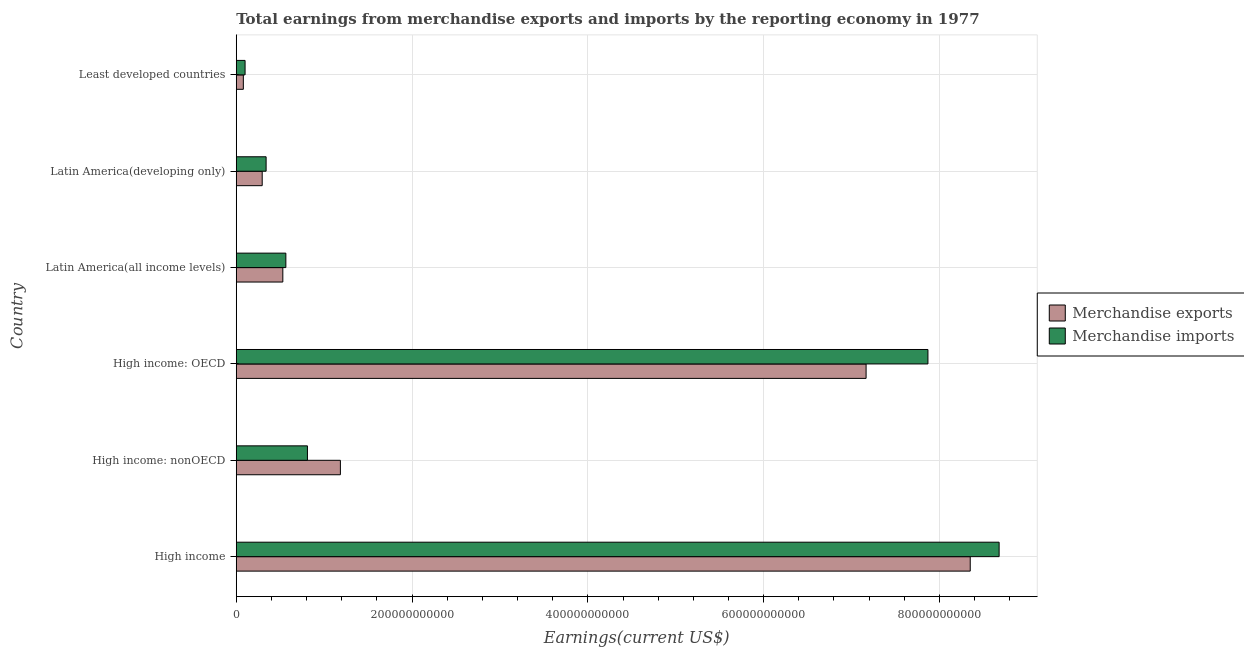Are the number of bars per tick equal to the number of legend labels?
Your answer should be compact. Yes. Are the number of bars on each tick of the Y-axis equal?
Offer a terse response. Yes. How many bars are there on the 2nd tick from the top?
Offer a very short reply. 2. How many bars are there on the 1st tick from the bottom?
Provide a short and direct response. 2. What is the label of the 1st group of bars from the top?
Offer a terse response. Least developed countries. What is the earnings from merchandise imports in Latin America(all income levels)?
Make the answer very short. 5.64e+1. Across all countries, what is the maximum earnings from merchandise exports?
Offer a terse response. 8.35e+11. Across all countries, what is the minimum earnings from merchandise imports?
Give a very brief answer. 1.00e+1. In which country was the earnings from merchandise imports maximum?
Give a very brief answer. High income. In which country was the earnings from merchandise exports minimum?
Offer a very short reply. Least developed countries. What is the total earnings from merchandise imports in the graph?
Make the answer very short. 1.84e+12. What is the difference between the earnings from merchandise imports in Latin America(all income levels) and that in Latin America(developing only)?
Your answer should be compact. 2.25e+1. What is the difference between the earnings from merchandise imports in Least developed countries and the earnings from merchandise exports in Latin America(all income levels)?
Your answer should be compact. -4.29e+1. What is the average earnings from merchandise exports per country?
Provide a short and direct response. 2.93e+11. What is the difference between the earnings from merchandise imports and earnings from merchandise exports in High income: nonOECD?
Your answer should be very brief. -3.75e+1. In how many countries, is the earnings from merchandise imports greater than 440000000000 US$?
Make the answer very short. 2. What is the ratio of the earnings from merchandise imports in High income to that in Latin America(all income levels)?
Provide a succinct answer. 15.38. What is the difference between the highest and the second highest earnings from merchandise exports?
Offer a very short reply. 1.18e+11. What is the difference between the highest and the lowest earnings from merchandise exports?
Make the answer very short. 8.27e+11. In how many countries, is the earnings from merchandise imports greater than the average earnings from merchandise imports taken over all countries?
Your answer should be compact. 2. What does the 1st bar from the bottom in Least developed countries represents?
Give a very brief answer. Merchandise exports. How many bars are there?
Your answer should be very brief. 12. Are all the bars in the graph horizontal?
Your response must be concise. Yes. What is the difference between two consecutive major ticks on the X-axis?
Provide a short and direct response. 2.00e+11. Are the values on the major ticks of X-axis written in scientific E-notation?
Keep it short and to the point. No. Does the graph contain any zero values?
Provide a short and direct response. No. Does the graph contain grids?
Provide a succinct answer. Yes. Where does the legend appear in the graph?
Make the answer very short. Center right. What is the title of the graph?
Provide a short and direct response. Total earnings from merchandise exports and imports by the reporting economy in 1977. What is the label or title of the X-axis?
Your answer should be compact. Earnings(current US$). What is the Earnings(current US$) in Merchandise exports in High income?
Make the answer very short. 8.35e+11. What is the Earnings(current US$) in Merchandise imports in High income?
Keep it short and to the point. 8.68e+11. What is the Earnings(current US$) in Merchandise exports in High income: nonOECD?
Offer a very short reply. 1.18e+11. What is the Earnings(current US$) of Merchandise imports in High income: nonOECD?
Your answer should be compact. 8.10e+1. What is the Earnings(current US$) in Merchandise exports in High income: OECD?
Your response must be concise. 7.17e+11. What is the Earnings(current US$) in Merchandise imports in High income: OECD?
Offer a terse response. 7.87e+11. What is the Earnings(current US$) in Merchandise exports in Latin America(all income levels)?
Provide a short and direct response. 5.30e+1. What is the Earnings(current US$) of Merchandise imports in Latin America(all income levels)?
Keep it short and to the point. 5.64e+1. What is the Earnings(current US$) in Merchandise exports in Latin America(developing only)?
Give a very brief answer. 2.95e+1. What is the Earnings(current US$) in Merchandise imports in Latin America(developing only)?
Provide a succinct answer. 3.40e+1. What is the Earnings(current US$) in Merchandise exports in Least developed countries?
Provide a succinct answer. 8.06e+09. What is the Earnings(current US$) in Merchandise imports in Least developed countries?
Make the answer very short. 1.00e+1. Across all countries, what is the maximum Earnings(current US$) in Merchandise exports?
Your answer should be compact. 8.35e+11. Across all countries, what is the maximum Earnings(current US$) of Merchandise imports?
Your response must be concise. 8.68e+11. Across all countries, what is the minimum Earnings(current US$) of Merchandise exports?
Your answer should be compact. 8.06e+09. Across all countries, what is the minimum Earnings(current US$) in Merchandise imports?
Keep it short and to the point. 1.00e+1. What is the total Earnings(current US$) in Merchandise exports in the graph?
Give a very brief answer. 1.76e+12. What is the total Earnings(current US$) in Merchandise imports in the graph?
Offer a very short reply. 1.84e+12. What is the difference between the Earnings(current US$) of Merchandise exports in High income and that in High income: nonOECD?
Ensure brevity in your answer.  7.17e+11. What is the difference between the Earnings(current US$) in Merchandise imports in High income and that in High income: nonOECD?
Your answer should be compact. 7.87e+11. What is the difference between the Earnings(current US$) of Merchandise exports in High income and that in High income: OECD?
Ensure brevity in your answer.  1.18e+11. What is the difference between the Earnings(current US$) in Merchandise imports in High income and that in High income: OECD?
Offer a terse response. 8.10e+1. What is the difference between the Earnings(current US$) of Merchandise exports in High income and that in Latin America(all income levels)?
Offer a terse response. 7.82e+11. What is the difference between the Earnings(current US$) in Merchandise imports in High income and that in Latin America(all income levels)?
Ensure brevity in your answer.  8.11e+11. What is the difference between the Earnings(current US$) in Merchandise exports in High income and that in Latin America(developing only)?
Provide a short and direct response. 8.05e+11. What is the difference between the Earnings(current US$) of Merchandise imports in High income and that in Latin America(developing only)?
Make the answer very short. 8.34e+11. What is the difference between the Earnings(current US$) of Merchandise exports in High income and that in Least developed countries?
Provide a short and direct response. 8.27e+11. What is the difference between the Earnings(current US$) of Merchandise imports in High income and that in Least developed countries?
Your response must be concise. 8.58e+11. What is the difference between the Earnings(current US$) of Merchandise exports in High income: nonOECD and that in High income: OECD?
Make the answer very short. -5.98e+11. What is the difference between the Earnings(current US$) in Merchandise imports in High income: nonOECD and that in High income: OECD?
Ensure brevity in your answer.  -7.06e+11. What is the difference between the Earnings(current US$) in Merchandise exports in High income: nonOECD and that in Latin America(all income levels)?
Make the answer very short. 6.55e+1. What is the difference between the Earnings(current US$) in Merchandise imports in High income: nonOECD and that in Latin America(all income levels)?
Your response must be concise. 2.46e+1. What is the difference between the Earnings(current US$) in Merchandise exports in High income: nonOECD and that in Latin America(developing only)?
Your answer should be compact. 8.89e+1. What is the difference between the Earnings(current US$) in Merchandise imports in High income: nonOECD and that in Latin America(developing only)?
Provide a short and direct response. 4.70e+1. What is the difference between the Earnings(current US$) of Merchandise exports in High income: nonOECD and that in Least developed countries?
Offer a terse response. 1.10e+11. What is the difference between the Earnings(current US$) of Merchandise imports in High income: nonOECD and that in Least developed countries?
Offer a terse response. 7.09e+1. What is the difference between the Earnings(current US$) in Merchandise exports in High income: OECD and that in Latin America(all income levels)?
Your answer should be compact. 6.64e+11. What is the difference between the Earnings(current US$) in Merchandise imports in High income: OECD and that in Latin America(all income levels)?
Make the answer very short. 7.30e+11. What is the difference between the Earnings(current US$) in Merchandise exports in High income: OECD and that in Latin America(developing only)?
Provide a short and direct response. 6.87e+11. What is the difference between the Earnings(current US$) of Merchandise imports in High income: OECD and that in Latin America(developing only)?
Give a very brief answer. 7.53e+11. What is the difference between the Earnings(current US$) of Merchandise exports in High income: OECD and that in Least developed countries?
Provide a short and direct response. 7.08e+11. What is the difference between the Earnings(current US$) of Merchandise imports in High income: OECD and that in Least developed countries?
Offer a very short reply. 7.77e+11. What is the difference between the Earnings(current US$) of Merchandise exports in Latin America(all income levels) and that in Latin America(developing only)?
Offer a very short reply. 2.35e+1. What is the difference between the Earnings(current US$) in Merchandise imports in Latin America(all income levels) and that in Latin America(developing only)?
Your response must be concise. 2.25e+1. What is the difference between the Earnings(current US$) of Merchandise exports in Latin America(all income levels) and that in Least developed countries?
Give a very brief answer. 4.49e+1. What is the difference between the Earnings(current US$) in Merchandise imports in Latin America(all income levels) and that in Least developed countries?
Provide a succinct answer. 4.64e+1. What is the difference between the Earnings(current US$) of Merchandise exports in Latin America(developing only) and that in Least developed countries?
Your response must be concise. 2.15e+1. What is the difference between the Earnings(current US$) of Merchandise imports in Latin America(developing only) and that in Least developed countries?
Ensure brevity in your answer.  2.39e+1. What is the difference between the Earnings(current US$) in Merchandise exports in High income and the Earnings(current US$) in Merchandise imports in High income: nonOECD?
Keep it short and to the point. 7.54e+11. What is the difference between the Earnings(current US$) in Merchandise exports in High income and the Earnings(current US$) in Merchandise imports in High income: OECD?
Your response must be concise. 4.81e+1. What is the difference between the Earnings(current US$) in Merchandise exports in High income and the Earnings(current US$) in Merchandise imports in Latin America(all income levels)?
Make the answer very short. 7.79e+11. What is the difference between the Earnings(current US$) in Merchandise exports in High income and the Earnings(current US$) in Merchandise imports in Latin America(developing only)?
Make the answer very short. 8.01e+11. What is the difference between the Earnings(current US$) in Merchandise exports in High income and the Earnings(current US$) in Merchandise imports in Least developed countries?
Ensure brevity in your answer.  8.25e+11. What is the difference between the Earnings(current US$) of Merchandise exports in High income: nonOECD and the Earnings(current US$) of Merchandise imports in High income: OECD?
Provide a short and direct response. -6.68e+11. What is the difference between the Earnings(current US$) in Merchandise exports in High income: nonOECD and the Earnings(current US$) in Merchandise imports in Latin America(all income levels)?
Ensure brevity in your answer.  6.20e+1. What is the difference between the Earnings(current US$) of Merchandise exports in High income: nonOECD and the Earnings(current US$) of Merchandise imports in Latin America(developing only)?
Provide a short and direct response. 8.45e+1. What is the difference between the Earnings(current US$) in Merchandise exports in High income: nonOECD and the Earnings(current US$) in Merchandise imports in Least developed countries?
Ensure brevity in your answer.  1.08e+11. What is the difference between the Earnings(current US$) in Merchandise exports in High income: OECD and the Earnings(current US$) in Merchandise imports in Latin America(all income levels)?
Your response must be concise. 6.60e+11. What is the difference between the Earnings(current US$) in Merchandise exports in High income: OECD and the Earnings(current US$) in Merchandise imports in Latin America(developing only)?
Keep it short and to the point. 6.83e+11. What is the difference between the Earnings(current US$) in Merchandise exports in High income: OECD and the Earnings(current US$) in Merchandise imports in Least developed countries?
Your response must be concise. 7.06e+11. What is the difference between the Earnings(current US$) in Merchandise exports in Latin America(all income levels) and the Earnings(current US$) in Merchandise imports in Latin America(developing only)?
Offer a very short reply. 1.90e+1. What is the difference between the Earnings(current US$) of Merchandise exports in Latin America(all income levels) and the Earnings(current US$) of Merchandise imports in Least developed countries?
Provide a succinct answer. 4.29e+1. What is the difference between the Earnings(current US$) of Merchandise exports in Latin America(developing only) and the Earnings(current US$) of Merchandise imports in Least developed countries?
Give a very brief answer. 1.95e+1. What is the average Earnings(current US$) in Merchandise exports per country?
Give a very brief answer. 2.93e+11. What is the average Earnings(current US$) in Merchandise imports per country?
Provide a short and direct response. 3.06e+11. What is the difference between the Earnings(current US$) in Merchandise exports and Earnings(current US$) in Merchandise imports in High income?
Give a very brief answer. -3.29e+1. What is the difference between the Earnings(current US$) of Merchandise exports and Earnings(current US$) of Merchandise imports in High income: nonOECD?
Make the answer very short. 3.75e+1. What is the difference between the Earnings(current US$) of Merchandise exports and Earnings(current US$) of Merchandise imports in High income: OECD?
Make the answer very short. -7.04e+1. What is the difference between the Earnings(current US$) in Merchandise exports and Earnings(current US$) in Merchandise imports in Latin America(all income levels)?
Ensure brevity in your answer.  -3.45e+09. What is the difference between the Earnings(current US$) in Merchandise exports and Earnings(current US$) in Merchandise imports in Latin America(developing only)?
Provide a short and direct response. -4.44e+09. What is the difference between the Earnings(current US$) in Merchandise exports and Earnings(current US$) in Merchandise imports in Least developed countries?
Keep it short and to the point. -1.98e+09. What is the ratio of the Earnings(current US$) of Merchandise exports in High income to that in High income: nonOECD?
Your answer should be compact. 7.05. What is the ratio of the Earnings(current US$) of Merchandise imports in High income to that in High income: nonOECD?
Make the answer very short. 10.72. What is the ratio of the Earnings(current US$) in Merchandise exports in High income to that in High income: OECD?
Make the answer very short. 1.17. What is the ratio of the Earnings(current US$) of Merchandise imports in High income to that in High income: OECD?
Offer a terse response. 1.1. What is the ratio of the Earnings(current US$) in Merchandise exports in High income to that in Latin America(all income levels)?
Make the answer very short. 15.76. What is the ratio of the Earnings(current US$) of Merchandise imports in High income to that in Latin America(all income levels)?
Make the answer very short. 15.38. What is the ratio of the Earnings(current US$) of Merchandise exports in High income to that in Latin America(developing only)?
Offer a terse response. 28.28. What is the ratio of the Earnings(current US$) in Merchandise imports in High income to that in Latin America(developing only)?
Offer a terse response. 25.55. What is the ratio of the Earnings(current US$) in Merchandise exports in High income to that in Least developed countries?
Provide a succinct answer. 103.63. What is the ratio of the Earnings(current US$) in Merchandise imports in High income to that in Least developed countries?
Provide a succinct answer. 86.44. What is the ratio of the Earnings(current US$) in Merchandise exports in High income: nonOECD to that in High income: OECD?
Your answer should be compact. 0.17. What is the ratio of the Earnings(current US$) of Merchandise imports in High income: nonOECD to that in High income: OECD?
Make the answer very short. 0.1. What is the ratio of the Earnings(current US$) in Merchandise exports in High income: nonOECD to that in Latin America(all income levels)?
Offer a very short reply. 2.24. What is the ratio of the Earnings(current US$) in Merchandise imports in High income: nonOECD to that in Latin America(all income levels)?
Your answer should be compact. 1.44. What is the ratio of the Earnings(current US$) in Merchandise exports in High income: nonOECD to that in Latin America(developing only)?
Your answer should be compact. 4.01. What is the ratio of the Earnings(current US$) in Merchandise imports in High income: nonOECD to that in Latin America(developing only)?
Keep it short and to the point. 2.38. What is the ratio of the Earnings(current US$) in Merchandise exports in High income: nonOECD to that in Least developed countries?
Ensure brevity in your answer.  14.7. What is the ratio of the Earnings(current US$) of Merchandise imports in High income: nonOECD to that in Least developed countries?
Offer a terse response. 8.07. What is the ratio of the Earnings(current US$) in Merchandise exports in High income: OECD to that in Latin America(all income levels)?
Make the answer very short. 13.53. What is the ratio of the Earnings(current US$) of Merchandise imports in High income: OECD to that in Latin America(all income levels)?
Offer a very short reply. 13.94. What is the ratio of the Earnings(current US$) in Merchandise exports in High income: OECD to that in Latin America(developing only)?
Offer a terse response. 24.27. What is the ratio of the Earnings(current US$) of Merchandise imports in High income: OECD to that in Latin America(developing only)?
Your response must be concise. 23.17. What is the ratio of the Earnings(current US$) of Merchandise exports in High income: OECD to that in Least developed countries?
Your answer should be compact. 88.93. What is the ratio of the Earnings(current US$) of Merchandise imports in High income: OECD to that in Least developed countries?
Your answer should be compact. 78.38. What is the ratio of the Earnings(current US$) in Merchandise exports in Latin America(all income levels) to that in Latin America(developing only)?
Your response must be concise. 1.79. What is the ratio of the Earnings(current US$) in Merchandise imports in Latin America(all income levels) to that in Latin America(developing only)?
Offer a very short reply. 1.66. What is the ratio of the Earnings(current US$) of Merchandise exports in Latin America(all income levels) to that in Least developed countries?
Offer a terse response. 6.58. What is the ratio of the Earnings(current US$) in Merchandise imports in Latin America(all income levels) to that in Least developed countries?
Give a very brief answer. 5.62. What is the ratio of the Earnings(current US$) of Merchandise exports in Latin America(developing only) to that in Least developed countries?
Your response must be concise. 3.66. What is the ratio of the Earnings(current US$) in Merchandise imports in Latin America(developing only) to that in Least developed countries?
Give a very brief answer. 3.38. What is the difference between the highest and the second highest Earnings(current US$) of Merchandise exports?
Offer a very short reply. 1.18e+11. What is the difference between the highest and the second highest Earnings(current US$) in Merchandise imports?
Offer a very short reply. 8.10e+1. What is the difference between the highest and the lowest Earnings(current US$) of Merchandise exports?
Provide a short and direct response. 8.27e+11. What is the difference between the highest and the lowest Earnings(current US$) in Merchandise imports?
Give a very brief answer. 8.58e+11. 